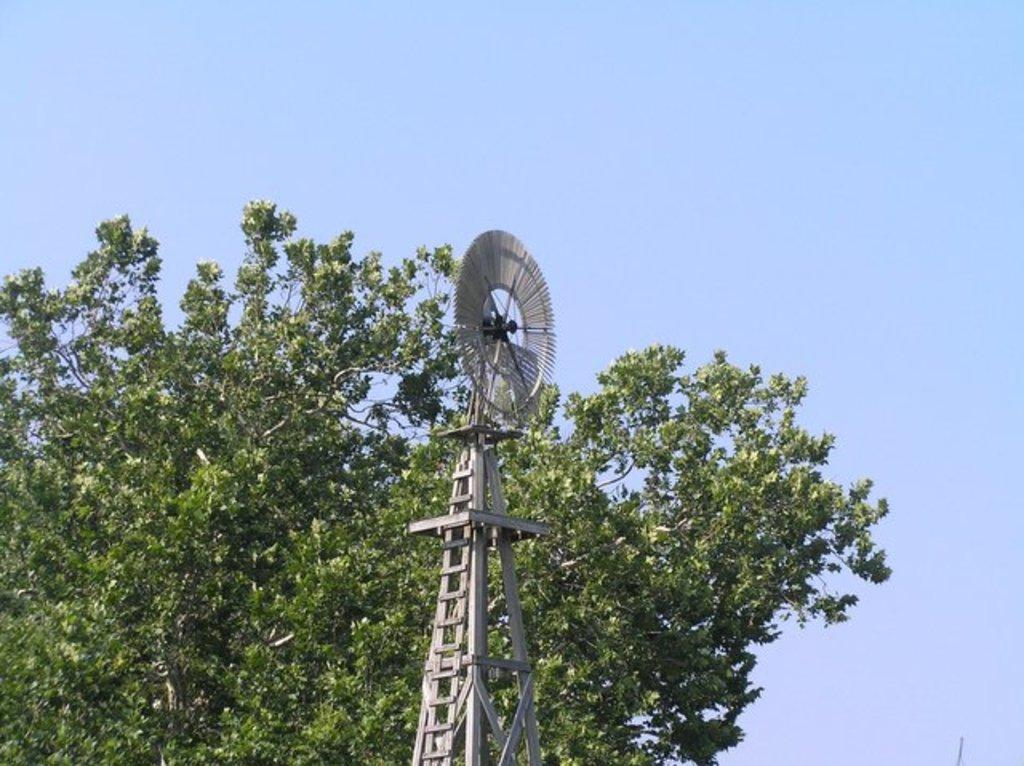What is the main subject in the center of the image? There is a tower and a tree in the center of the image. Can you describe the background of the image? The sky is visible in the background of the image. What color is the feather on the tree in the image? There is no feather present on the tree in the image. 